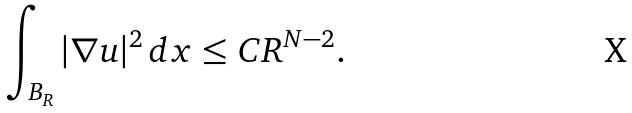<formula> <loc_0><loc_0><loc_500><loc_500>\int _ { B _ { R } } | \nabla u | ^ { 2 } \, d x \leq C R ^ { N - 2 } .</formula> 